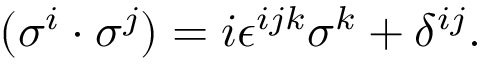Convert formula to latex. <formula><loc_0><loc_0><loc_500><loc_500>( \sigma ^ { i } \cdot \sigma ^ { j } ) = i \epsilon ^ { i j k } \sigma ^ { k } + \delta ^ { i j } .</formula> 